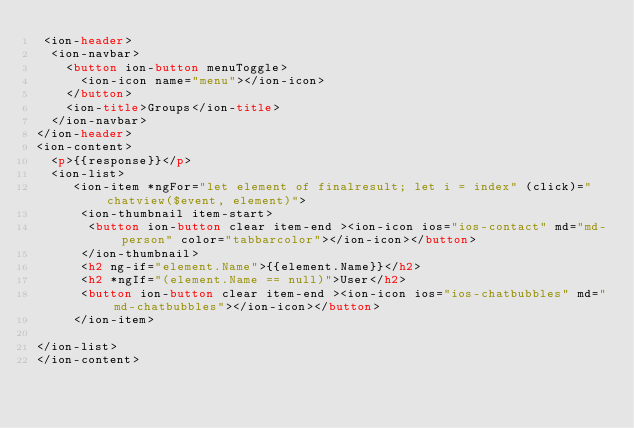Convert code to text. <code><loc_0><loc_0><loc_500><loc_500><_HTML_> <ion-header>
  <ion-navbar>
    <button ion-button menuToggle>
      <ion-icon name="menu"></ion-icon>
    </button>
    <ion-title>Groups</ion-title>
  </ion-navbar>
</ion-header>
<ion-content>
	<p>{{response}}</p>
	<ion-list>
		 <ion-item *ngFor="let element of finalresult; let i = index" (click)="chatview($event, element)">
			<ion-thumbnail item-start>
			 <button ion-button clear item-end ><ion-icon ios="ios-contact" md="md-person" color="tabbarcolor"></ion-icon></button>
			</ion-thumbnail>
			<h2 ng-if="element.Name">{{element.Name}}</h2>
			<h2 *ngIf="(element.Name == null)">User</h2>
			<button ion-button clear item-end ><ion-icon ios="ios-chatbubbles" md="md-chatbubbles"></ion-icon></button>
		 </ion-item> 
		
</ion-list>
</ion-content>
 
</code> 